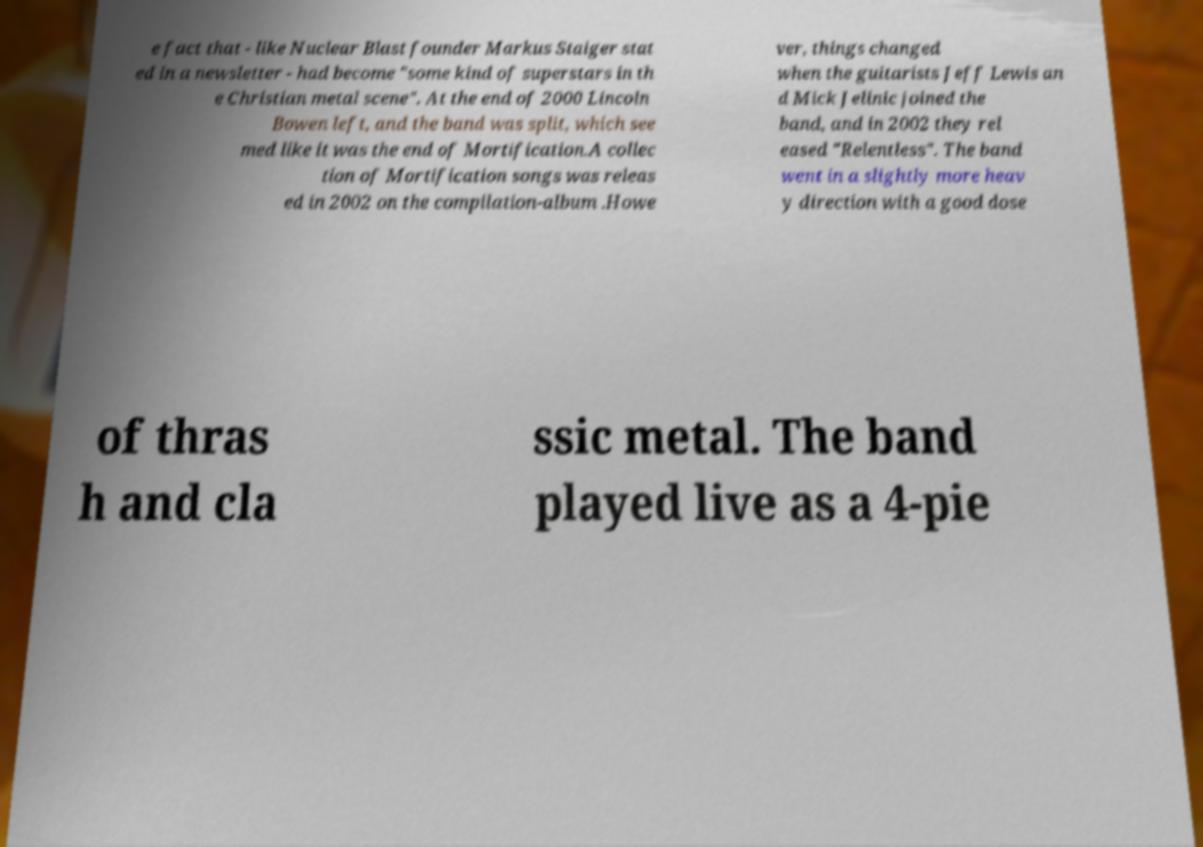Please identify and transcribe the text found in this image. e fact that - like Nuclear Blast founder Markus Staiger stat ed in a newsletter - had become "some kind of superstars in th e Christian metal scene". At the end of 2000 Lincoln Bowen left, and the band was split, which see med like it was the end of Mortification.A collec tion of Mortification songs was releas ed in 2002 on the compilation-album .Howe ver, things changed when the guitarists Jeff Lewis an d Mick Jelinic joined the band, and in 2002 they rel eased "Relentless". The band went in a slightly more heav y direction with a good dose of thras h and cla ssic metal. The band played live as a 4-pie 